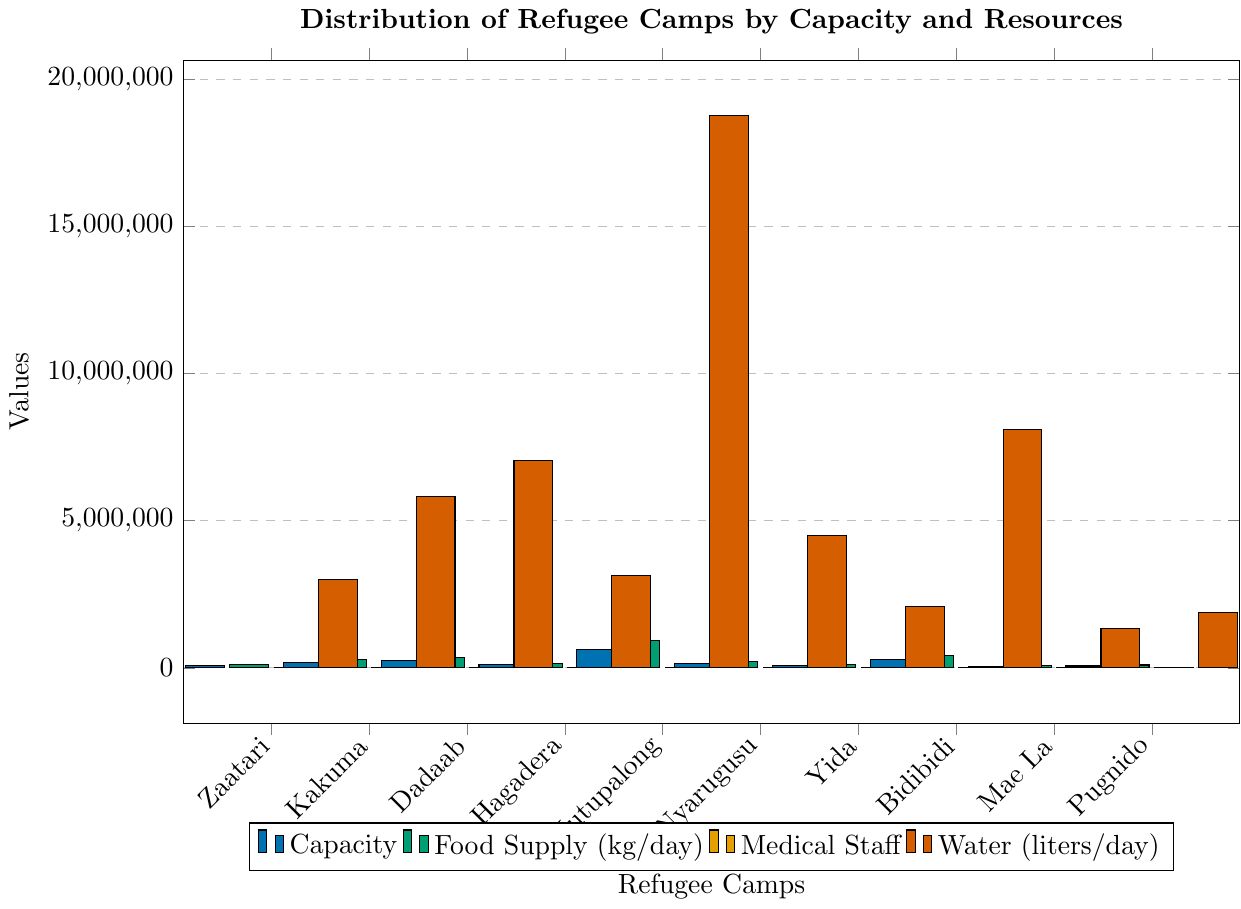Which refugee camp has the highest capacity? By looking at the heights of the blue bars representing capacity, the tallest blue bar corresponds to Kutupalong.
Answer: Kutupalong What is the difference in capacity between Kakuma and Dadaab? The blue bar for Kakuma indicates a capacity of 194,000, and for Dadaab, it shows 235,000. Subtracting these values gives 235,000 - 194,000 = 41,000.
Answer: 41,000 How much more food supply does Bidibidi have compared to Zaatari? The green bars for food supply show that Bidibidi has 405,000 kg/day, and Zaatari has 120,000 kg/day. Subtracting these values gives 405,000 - 120,000 = 285,000.
Answer: 285,000 Which camp has the least amount of medical staff, and how many do they have? The height of the orange bars indicates the number of medical staff. Mae La has the shortest orange bar, representing 80 medical staff.
Answer: Mae La, 80 What is the average water supply across all camps? Summing up the water (liters/day) values (3,000,000 + 5,820,000 + 7,050,000 + 3,150,000 + 18,780,000 + 4,500,000 + 2,100,000 + 8,100,000 + 1,350,000 + 1,890,000) equals 56,740,000. Dividing this by the number of camps (10) gives 56,740,000 / 10 = 5,674,000 liters/day.
Answer: 5,674,000 Which camp has the second highest number of medical staff? The orange bars for medical staff show the highest at Kutupalong with 450, and the second highest is Bidibidi with 320.
Answer: Bidibidi How many camps have a capacity greater than 200,000? By observing the heights of the blue bars for capacity, we can see that Dadaab (235,000), Kakuma (194,000), and Bidibidi (270,000) have capacities greater than 200,000.
Answer: 3 Compare the food supply of Kutupalong and Nyarugusu; which camp has more, and by how much? The green bars for food supply show that Kutupalong has 939,000 kg/day, and Nyarugusu has 225,000 kg/day. The difference is 939,000 - 225,000 = 714,000 kg/day.
Answer: Kutupalong, 714,000 What is the median capacity of the refugee camps? Listing the capacities in ascending order gives 45,000, 63,000, 70,000, 80,000, 105,000, 150,000, 194,000, 235,000, 270,000, 626,000. There are 10 camps, so the median is the average of the 5th and 6th values: (105,000 + 150,000) / 2 = 127,500.
Answer: 127,500 